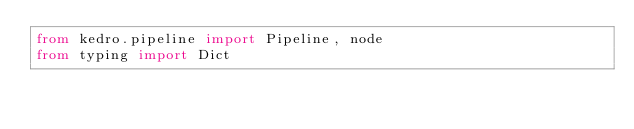<code> <loc_0><loc_0><loc_500><loc_500><_Python_>from kedro.pipeline import Pipeline, node
from typing import Dict</code> 